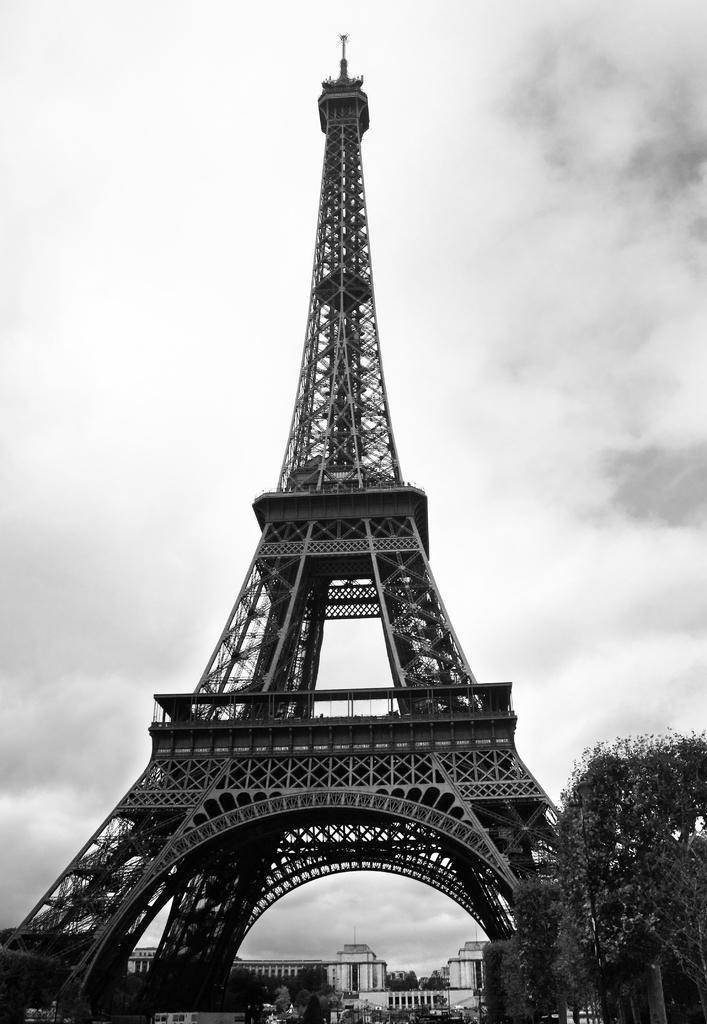Please provide a concise description of this image. In this image in the center there is a tower. In the background there are buildings and trees. In the front on the right side there is a tree and the sky is cloudy. 